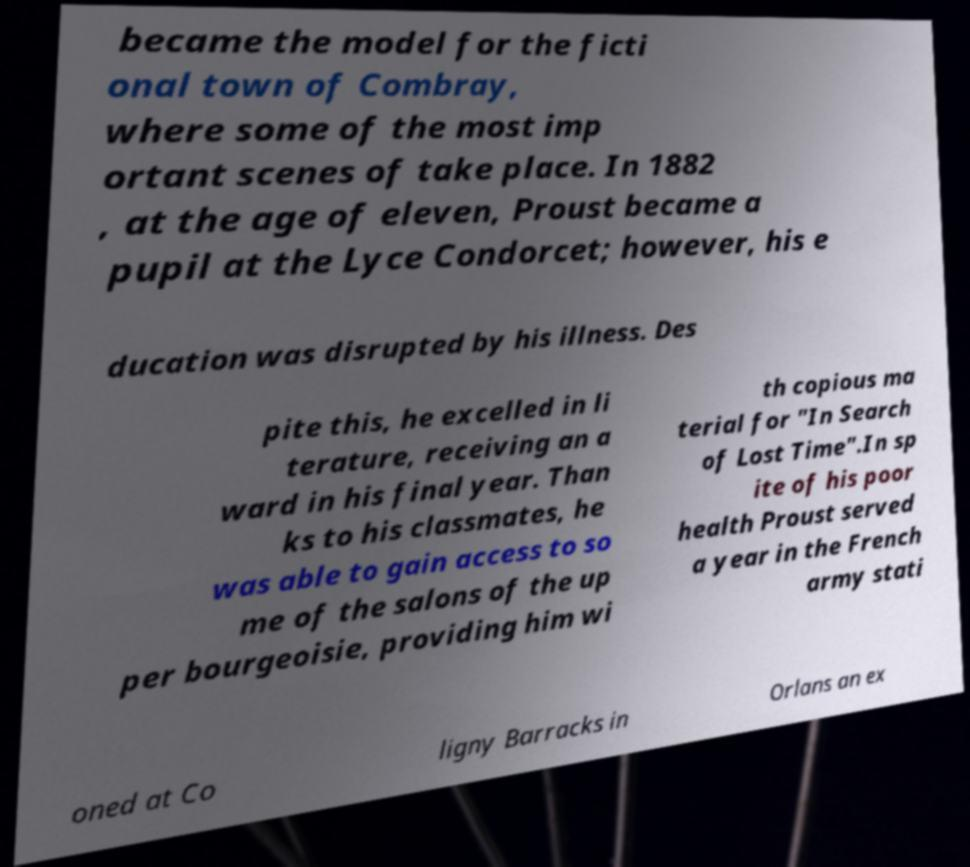What messages or text are displayed in this image? I need them in a readable, typed format. became the model for the ficti onal town of Combray, where some of the most imp ortant scenes of take place. In 1882 , at the age of eleven, Proust became a pupil at the Lyce Condorcet; however, his e ducation was disrupted by his illness. Des pite this, he excelled in li terature, receiving an a ward in his final year. Than ks to his classmates, he was able to gain access to so me of the salons of the up per bourgeoisie, providing him wi th copious ma terial for "In Search of Lost Time".In sp ite of his poor health Proust served a year in the French army stati oned at Co ligny Barracks in Orlans an ex 